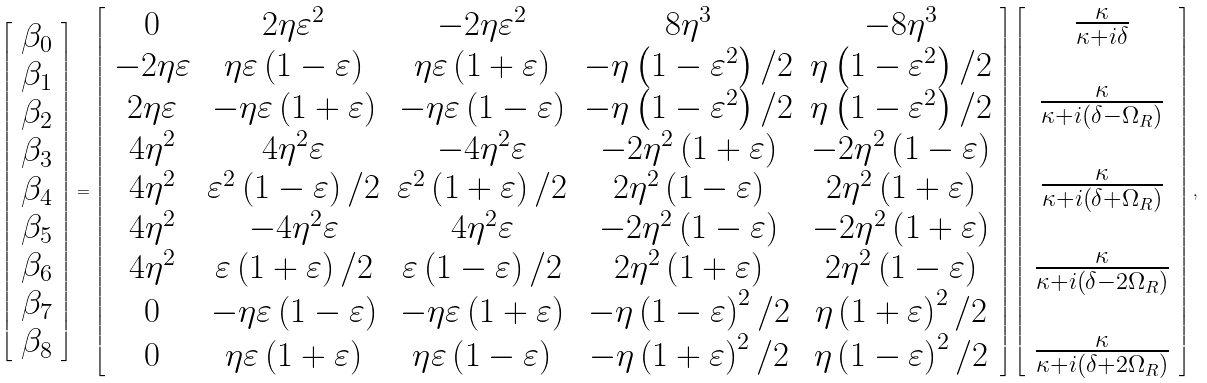<formula> <loc_0><loc_0><loc_500><loc_500>\left [ \begin{array} { l } \beta _ { 0 } \\ \beta _ { 1 } \\ \beta _ { 2 } \\ \beta _ { 3 } \\ \beta _ { 4 } \\ \beta _ { 5 } \\ \beta _ { 6 } \\ \beta _ { 7 } \\ \beta _ { 8 } \end{array} \right ] = \left [ \begin{array} { c c c c c } 0 & 2 \eta \varepsilon ^ { 2 } & - 2 \eta \varepsilon ^ { 2 } & 8 \eta ^ { 3 } & - 8 \eta ^ { 3 } \\ - 2 \eta \varepsilon & \eta \varepsilon \left ( 1 - \varepsilon \right ) & \eta \varepsilon \left ( 1 + \varepsilon \right ) & - \eta \left ( 1 - \varepsilon ^ { 2 } \right ) / 2 & \eta \left ( 1 - \varepsilon ^ { 2 } \right ) / 2 \\ 2 \eta \varepsilon & - \eta \varepsilon \left ( 1 + \varepsilon \right ) & - \eta \varepsilon \left ( 1 - \varepsilon \right ) & - \eta \left ( 1 - \varepsilon ^ { 2 } \right ) / 2 & \eta \left ( 1 - \varepsilon ^ { 2 } \right ) / 2 \\ 4 \eta ^ { 2 } & 4 \eta ^ { 2 } \varepsilon & - 4 \eta ^ { 2 } \varepsilon & - 2 \eta ^ { 2 } \left ( 1 + \varepsilon \right ) & - 2 \eta ^ { 2 } \left ( 1 - \varepsilon \right ) \\ 4 \eta ^ { 2 } & \varepsilon ^ { 2 } \left ( 1 - \varepsilon \right ) / 2 & \varepsilon ^ { 2 } \left ( 1 + \varepsilon \right ) / 2 & 2 \eta ^ { 2 } \left ( 1 - \varepsilon \right ) & 2 \eta ^ { 2 } \left ( 1 + \varepsilon \right ) \\ 4 \eta ^ { 2 } & - 4 \eta ^ { 2 } \varepsilon & 4 \eta ^ { 2 } \varepsilon & - 2 \eta ^ { 2 } \left ( 1 - \varepsilon \right ) & - 2 \eta ^ { 2 } \left ( 1 + \varepsilon \right ) \\ 4 \eta ^ { 2 } & \varepsilon \left ( 1 + \varepsilon \right ) / 2 & \varepsilon \left ( 1 - \varepsilon \right ) / 2 & 2 \eta ^ { 2 } \left ( 1 + \varepsilon \right ) & 2 \eta ^ { 2 } \left ( 1 - \varepsilon \right ) \\ 0 & - \eta \varepsilon \left ( 1 - \varepsilon \right ) & - \eta \varepsilon \left ( 1 + \varepsilon \right ) & - \eta \left ( 1 - \varepsilon \right ) ^ { 2 } / 2 & \eta \left ( 1 + \varepsilon \right ) ^ { 2 } / 2 \\ 0 & \eta \varepsilon \left ( 1 + \varepsilon \right ) & \eta \varepsilon \left ( 1 - \varepsilon \right ) & - \eta \left ( 1 + \varepsilon \right ) ^ { 2 } / 2 & \eta \left ( 1 - \varepsilon \right ) ^ { 2 } / 2 \end{array} \right ] \left [ \begin{array} { c } \frac { \kappa } { \kappa + i \delta } \\ \\ \frac { \kappa } { \kappa + i \left ( \delta - \Omega _ { R } \right ) } \\ \\ \frac { \kappa } { \kappa + i \left ( \delta + \Omega _ { R } \right ) } \\ \\ \frac { \kappa } { \kappa + i \left ( \delta - 2 \Omega _ { R } \right ) } \\ \\ \frac { \kappa } { \kappa + i \left ( \delta + 2 \Omega _ { R } \right ) } \end{array} \right ] ,</formula> 